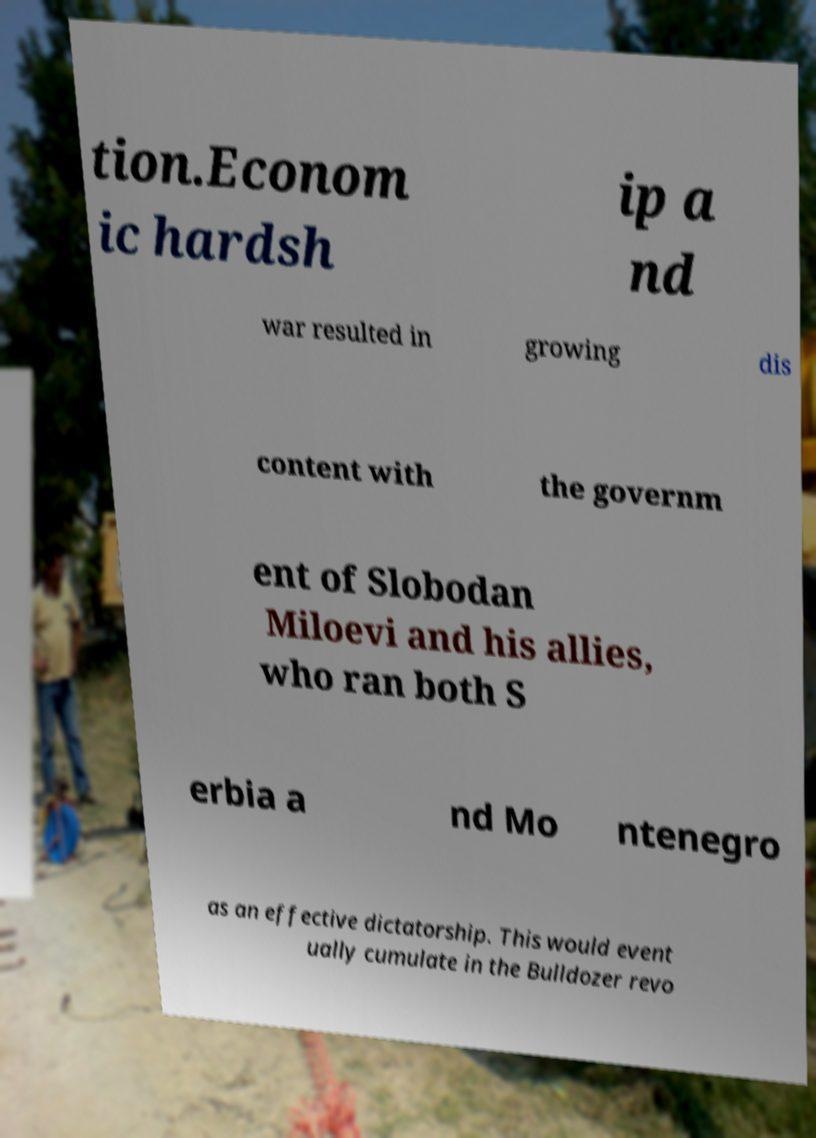I need the written content from this picture converted into text. Can you do that? tion.Econom ic hardsh ip a nd war resulted in growing dis content with the governm ent of Slobodan Miloevi and his allies, who ran both S erbia a nd Mo ntenegro as an effective dictatorship. This would event ually cumulate in the Bulldozer revo 